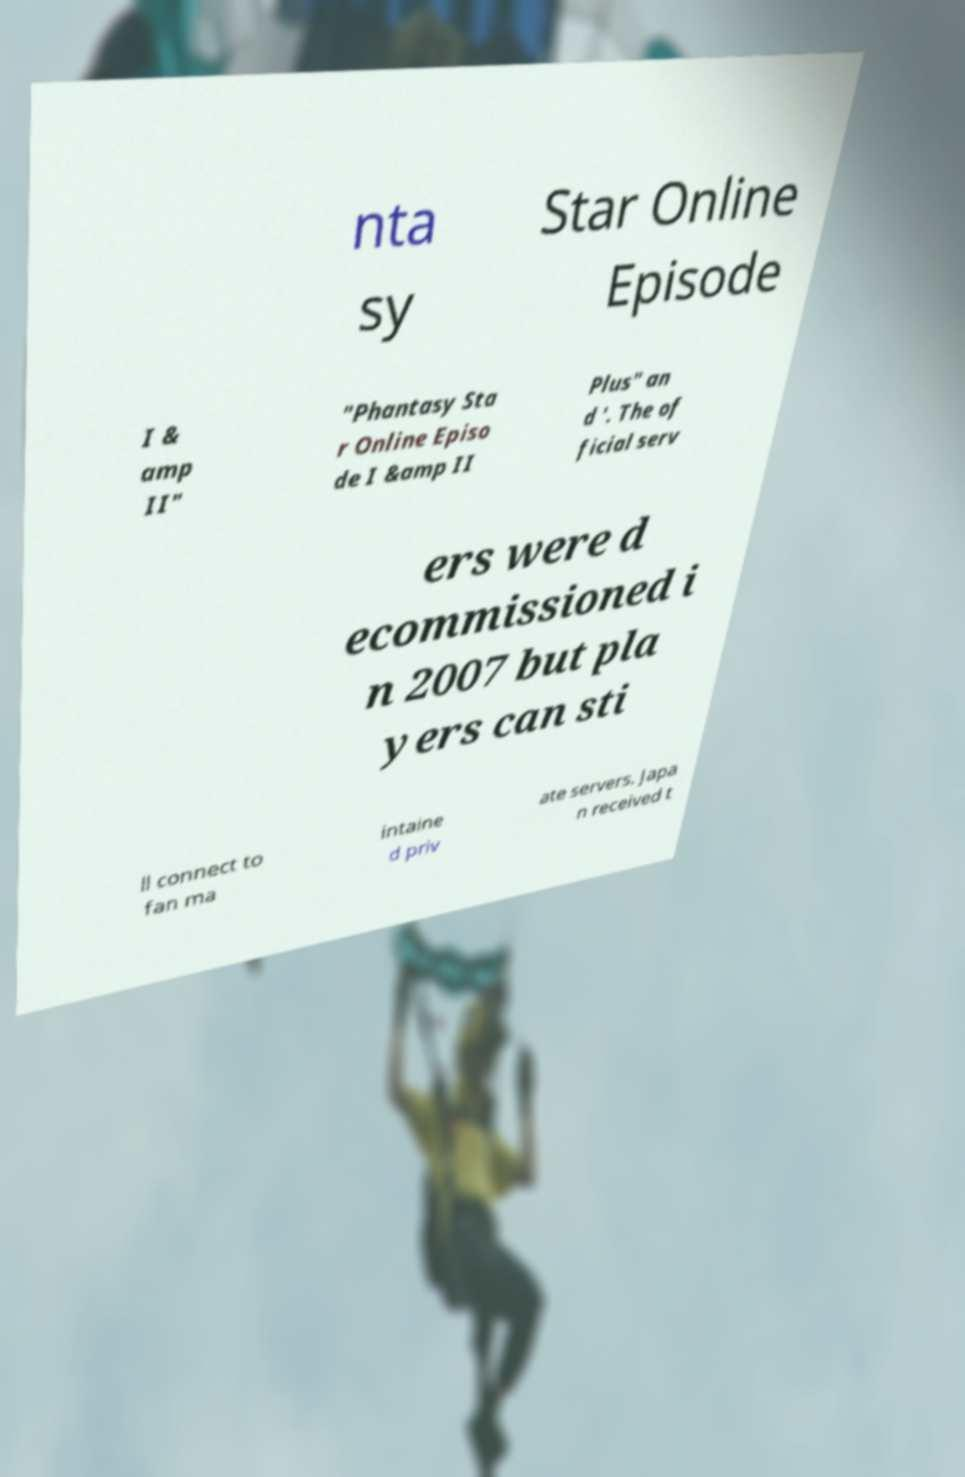Could you assist in decoding the text presented in this image and type it out clearly? nta sy Star Online Episode I & amp II" "Phantasy Sta r Online Episo de I &amp II Plus" an d '. The of ficial serv ers were d ecommissioned i n 2007 but pla yers can sti ll connect to fan ma intaine d priv ate servers. Japa n received t 